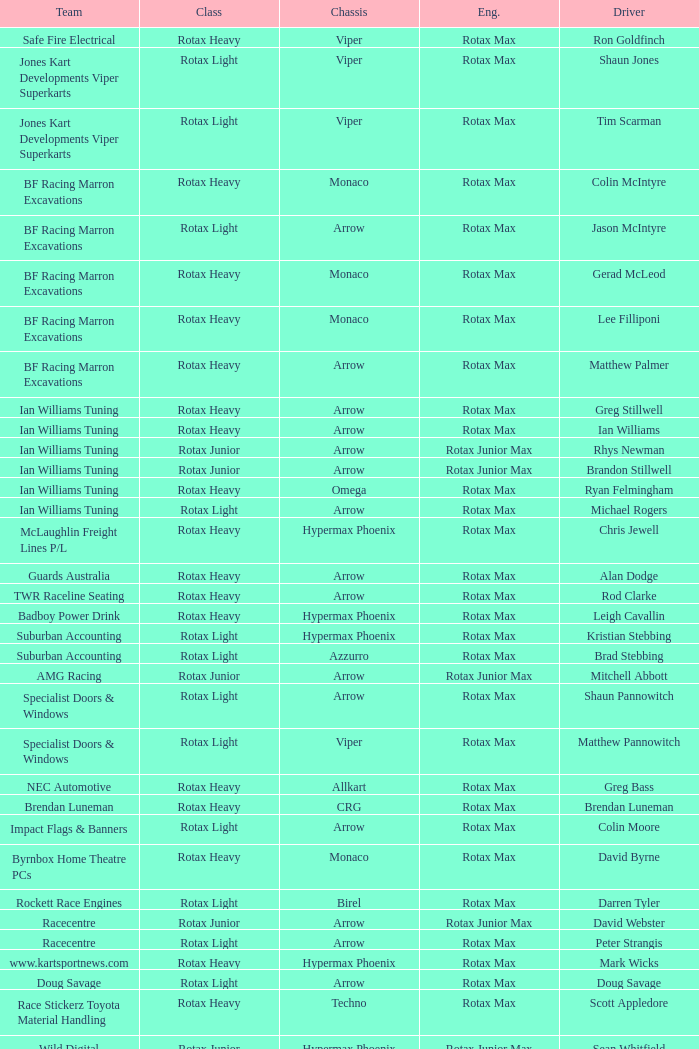Which team does Colin Moore drive for? Impact Flags & Banners. 